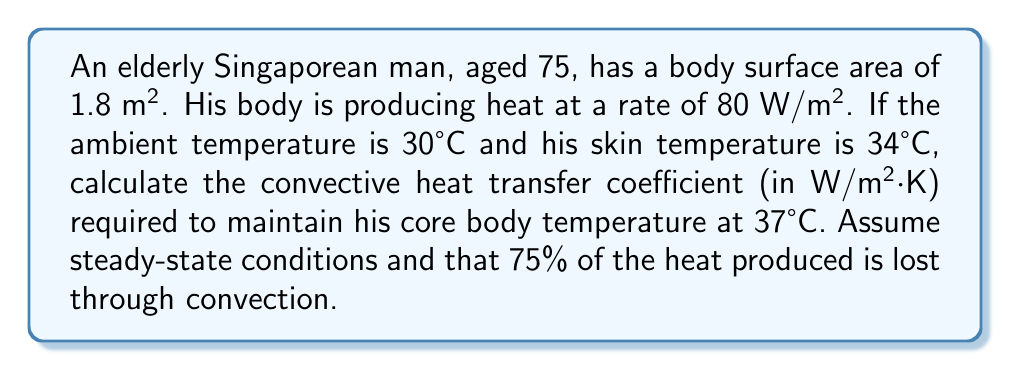Show me your answer to this math problem. Let's approach this step-by-step:

1) First, we need to calculate the total heat produced by the body:
   $$Q_{produced} = 80 \frac{W}{m^2} \times 1.8 m^2 = 144 W$$

2) We're told that 75% of this heat is lost through convection:
   $$Q_{convection} = 0.75 \times 144 W = 108 W$$

3) The convective heat transfer is governed by Newton's law of cooling:
   $$Q_{convection} = hA(T_{skin} - T_{ambient})$$
   where $h$ is the convective heat transfer coefficient, $A$ is the body surface area, $T_{skin}$ is the skin temperature, and $T_{ambient}$ is the ambient temperature.

4) Substituting our known values:
   $$108 W = h \times 1.8 m^2 \times (34°C - 30°C)$$

5) Simplifying:
   $$108 W = h \times 1.8 m^2 \times 4°C$$

6) Solving for $h$:
   $$h = \frac{108 W}{1.8 m^2 \times 4°C} = 15 \frac{W}{m^2 \cdot K}$$

Therefore, the required convective heat transfer coefficient is 15 W/m²·K.
Answer: 15 W/m²·K 